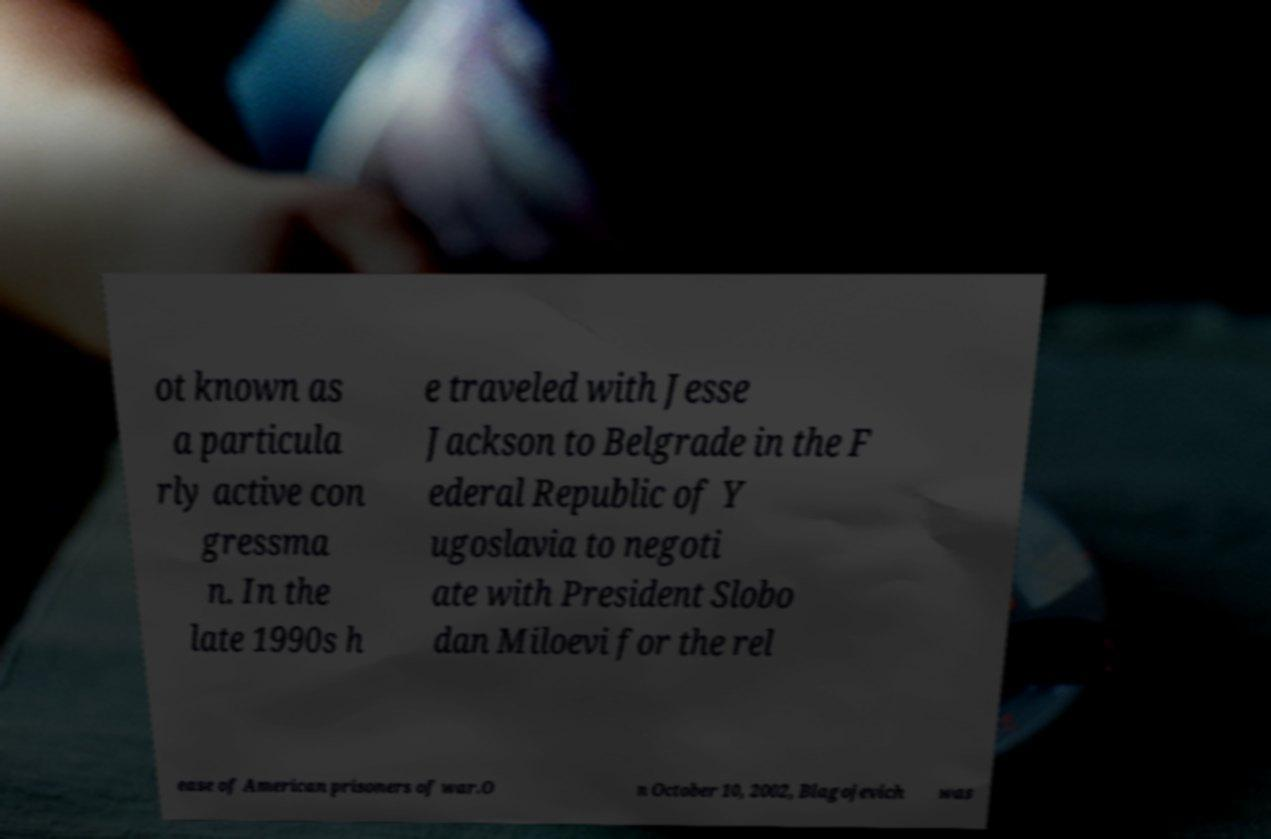Please read and relay the text visible in this image. What does it say? ot known as a particula rly active con gressma n. In the late 1990s h e traveled with Jesse Jackson to Belgrade in the F ederal Republic of Y ugoslavia to negoti ate with President Slobo dan Miloevi for the rel ease of American prisoners of war.O n October 10, 2002, Blagojevich was 